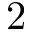<formula> <loc_0><loc_0><loc_500><loc_500>2</formula> 